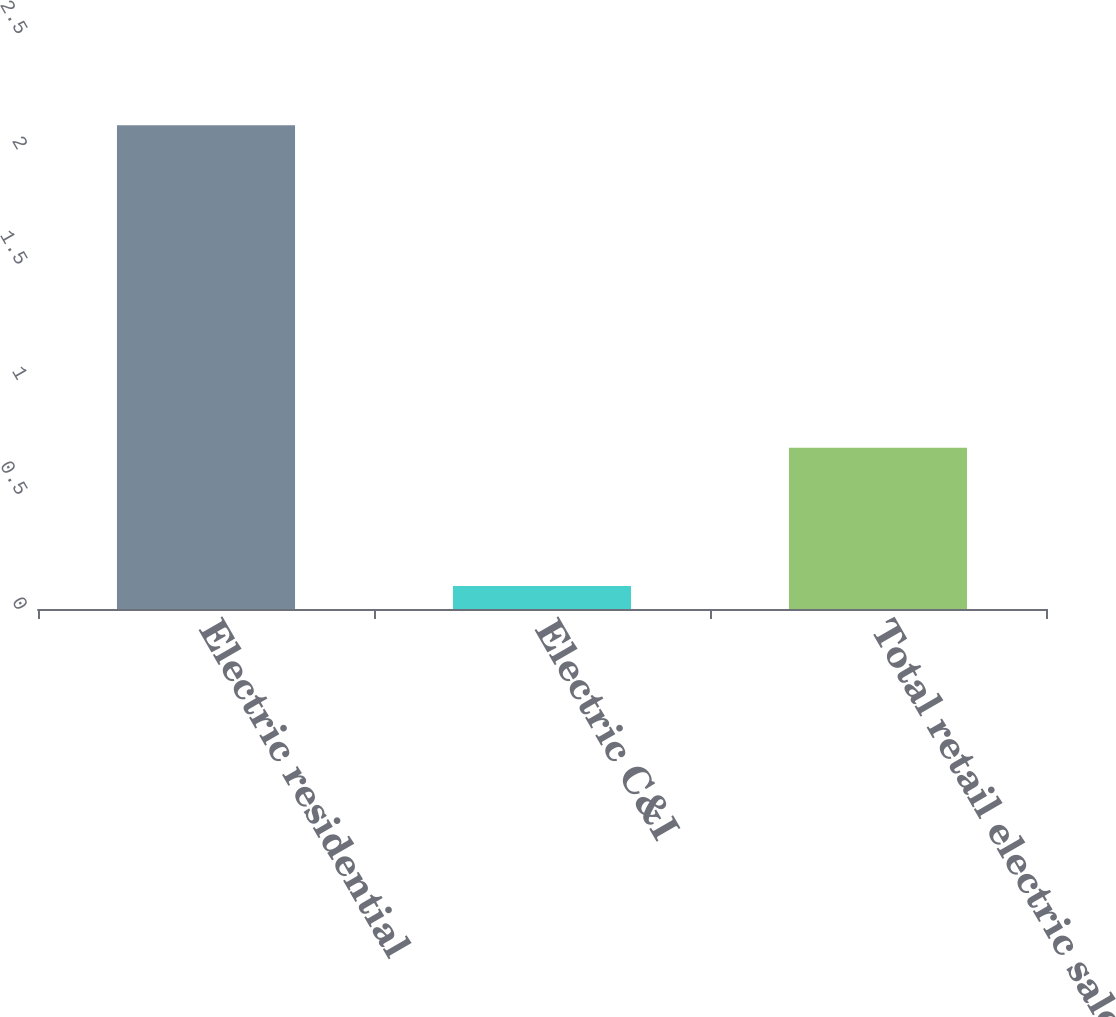Convert chart to OTSL. <chart><loc_0><loc_0><loc_500><loc_500><bar_chart><fcel>Electric residential<fcel>Electric C&I<fcel>Total retail electric sales<nl><fcel>2.1<fcel>0.1<fcel>0.7<nl></chart> 